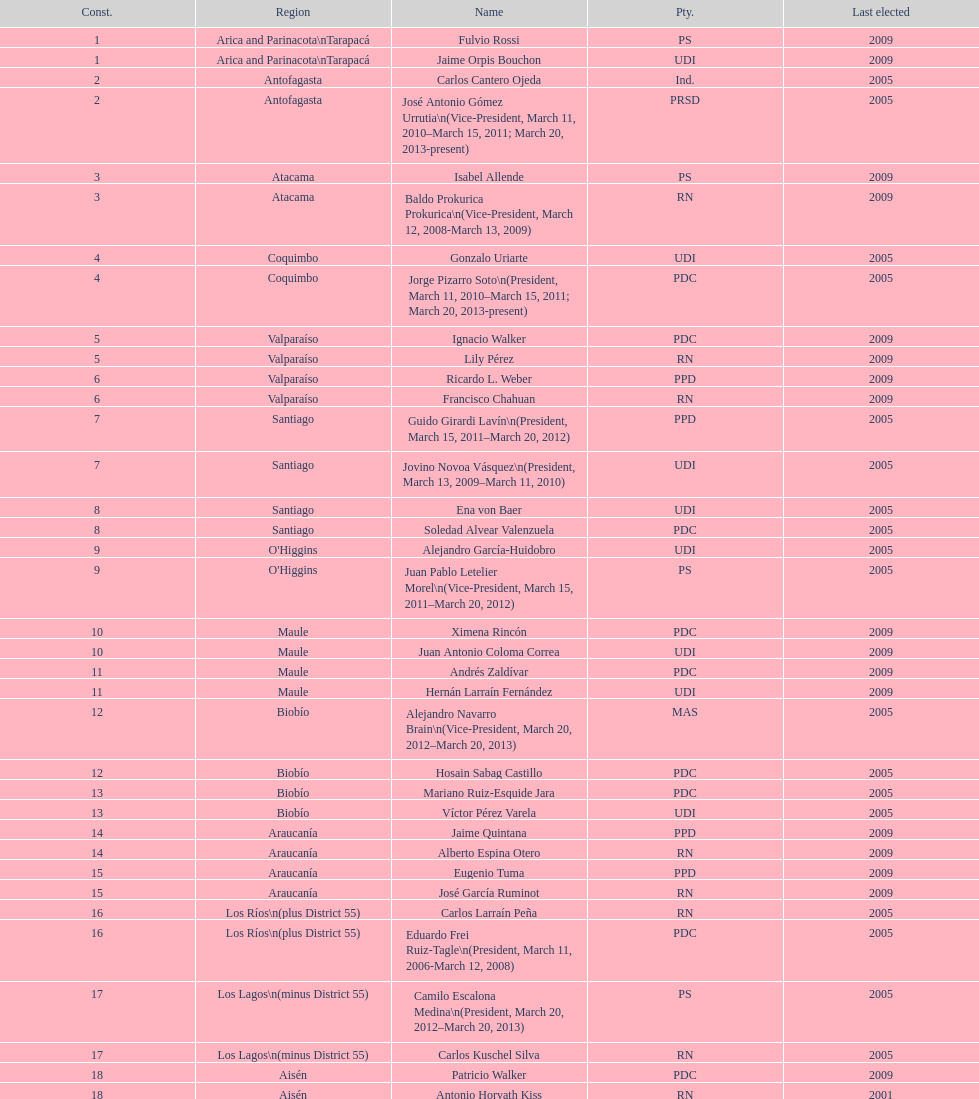Which region is listed below atacama? Coquimbo. 